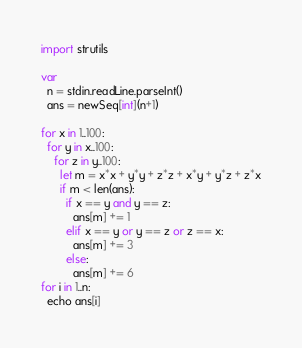<code> <loc_0><loc_0><loc_500><loc_500><_Nim_>import strutils

var
  n = stdin.readLine.parseInt()
  ans = newSeq[int](n+1)

for x in 1..100:
  for y in x..100:
    for z in y..100:
      let m = x*x + y*y + z*z + x*y + y*z + z*x
      if m < len(ans):
        if x == y and y == z:
          ans[m] += 1
        elif x == y or y == z or z == x:
          ans[m] += 3
        else:
          ans[m] += 6
for i in 1..n:
  echo ans[i]</code> 